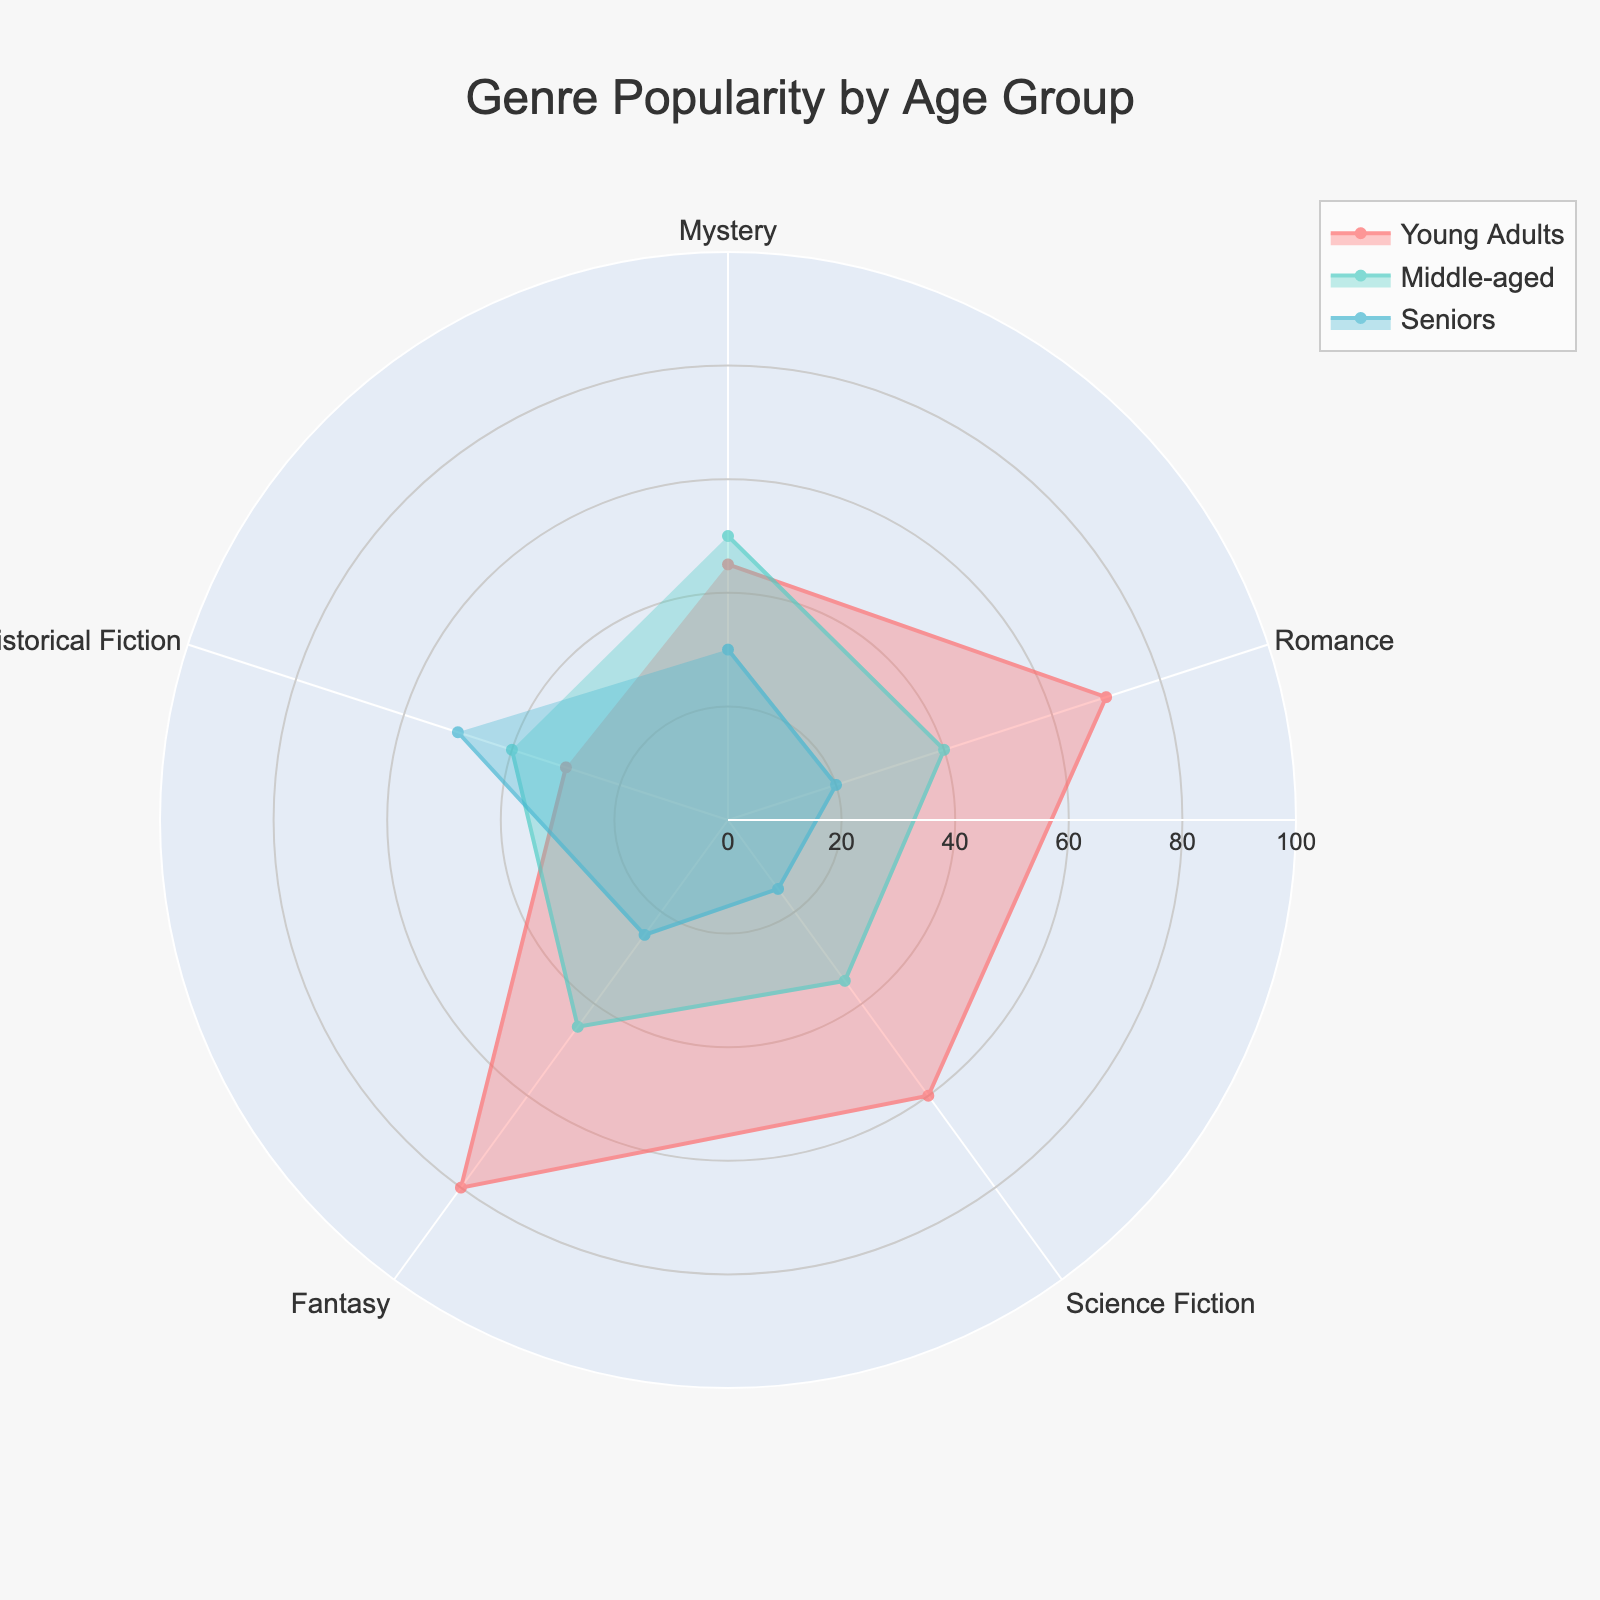What is the most popular genre among young adults? By looking at the radar chart, the genre with the highest value among young adults is Fantasy, showing the highest point on the plot.
Answer: Fantasy Which age group prefers Historical Fiction the most? Referring to the radar chart, the value for Historical Fiction is highest in the Seniors age group.
Answer: Seniors What is the difference in popularity for Mystery among middle-aged readers and seniors? The value for Mystery among middle-aged readers is 50, and for seniors, it's 30. The difference is 50 - 30.
Answer: 20 Which genre has the least popularity among seniors? The radar chart shows the lowest value for Romance among seniors, which is the smallest point on the plot for that age group.
Answer: Romance How does the popularity of Science Fiction compare between young adults and middle-aged readers? For Science Fiction, young adults have a value of 60, and middle-aged readers have a value of 35. 60 is greater than 35, indicating young adults prefer Science Fiction more.
Answer: Young adults prefer Science Fiction more Which genre shows the most balanced popularity across all age groups? Historical Fiction has relatively similar values across all age groups (30 for young adults, 40 for middle-aged, and 50 for seniors), indicating it is the most balanced.
Answer: Historical Fiction How much more popular is Fantasy among young adults compared to seniors? The value for Fantasy among young adults is 80, and for seniors, it is 25. The difference is 80 - 25.
Answer: 55 What is the average popularity of Romance across all age groups? The values for Romance are 70 for young adults, 40 for middle-aged, and 20 for seniors. The average is (70 + 40 + 20) / 3.
Answer: 43.33 Between Mystery and Romance, which genre has more consistent popularity across different age groups? Mystery has values of 45, 50, and 30 for young adults, middle-aged, and seniors, respectively, while Romance has values of 70, 40, and 20. Mystery values are closer to each other, indicating more consistency.
Answer: Mystery Compare the overall popularity trends of Science Fiction and Romance. Science Fiction is more popular among young adults (60) and has declining popularity as age increases (35 for middle-aged, 15 for seniors). On the other hand, Romance starts higher among young adults (70) but sees a sharper decline among middle-aged (40) and seniors (20).
Answer: Science Fiction declines steadily, while Romance has a sharper decline 